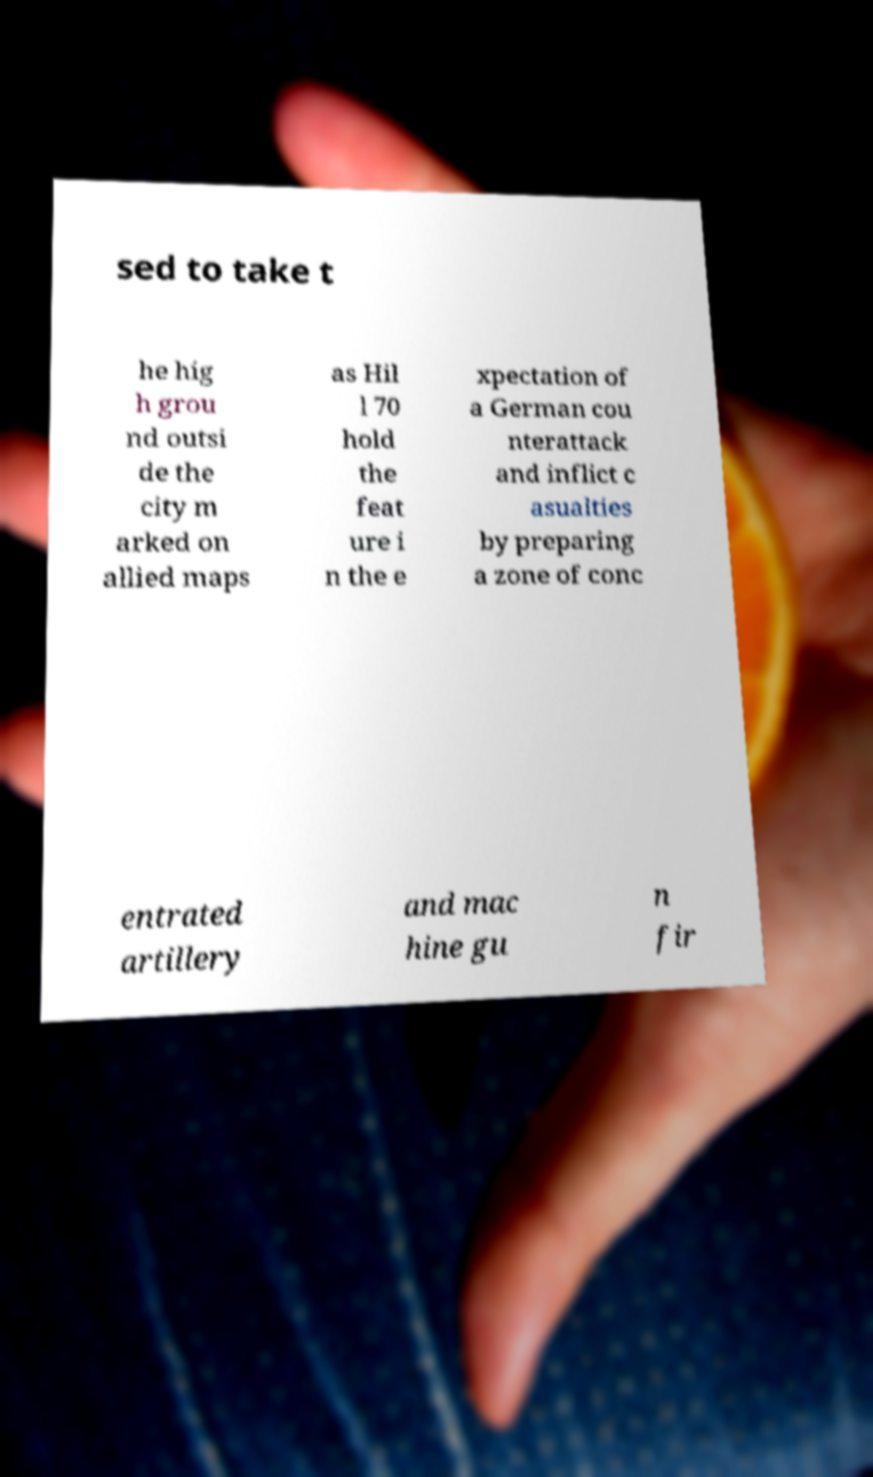Please read and relay the text visible in this image. What does it say? sed to take t he hig h grou nd outsi de the city m arked on allied maps as Hil l 70 hold the feat ure i n the e xpectation of a German cou nterattack and inflict c asualties by preparing a zone of conc entrated artillery and mac hine gu n fir 